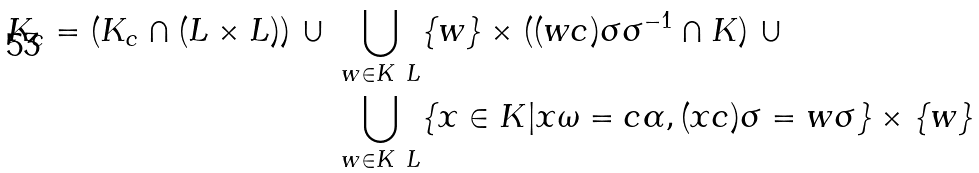<formula> <loc_0><loc_0><loc_500><loc_500>K _ { c } = ( K _ { c } \cap ( L \times L ) ) \ \cup \ & \bigcup _ { w \in K \ L } \{ w \} \times ( ( w c ) \sigma \sigma ^ { - 1 } \cap K ) \ \cup \\ & \bigcup _ { w \in K \ L } \{ x \in K | x \omega = c \alpha , ( x c ) \sigma = w \sigma \} \times \{ w \}</formula> 